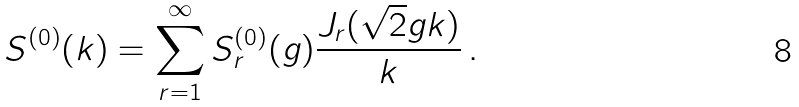Convert formula to latex. <formula><loc_0><loc_0><loc_500><loc_500>S ^ { ( 0 ) } ( k ) = \sum _ { r = 1 } ^ { \infty } S ^ { ( 0 ) } _ { r } ( g ) \frac { J _ { r } ( { \sqrt { 2 } } g k ) } { k } \, .</formula> 